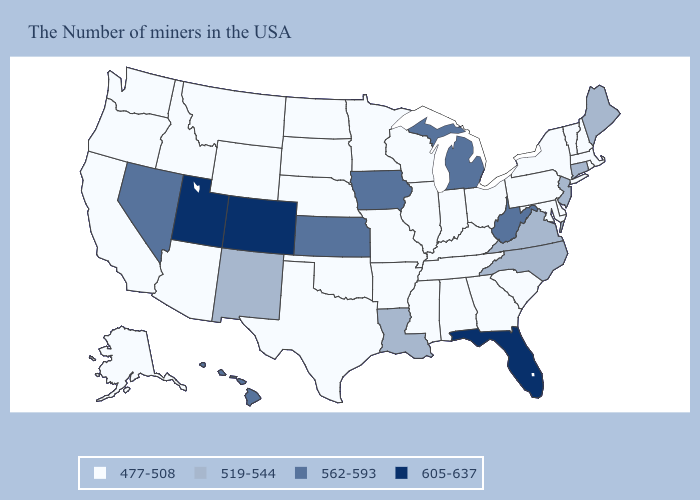Which states hav the highest value in the West?
Keep it brief. Colorado, Utah. Name the states that have a value in the range 477-508?
Write a very short answer. Massachusetts, Rhode Island, New Hampshire, Vermont, New York, Delaware, Maryland, Pennsylvania, South Carolina, Ohio, Georgia, Kentucky, Indiana, Alabama, Tennessee, Wisconsin, Illinois, Mississippi, Missouri, Arkansas, Minnesota, Nebraska, Oklahoma, Texas, South Dakota, North Dakota, Wyoming, Montana, Arizona, Idaho, California, Washington, Oregon, Alaska. Does Louisiana have a higher value than Indiana?
Write a very short answer. Yes. Which states have the lowest value in the USA?
Be succinct. Massachusetts, Rhode Island, New Hampshire, Vermont, New York, Delaware, Maryland, Pennsylvania, South Carolina, Ohio, Georgia, Kentucky, Indiana, Alabama, Tennessee, Wisconsin, Illinois, Mississippi, Missouri, Arkansas, Minnesota, Nebraska, Oklahoma, Texas, South Dakota, North Dakota, Wyoming, Montana, Arizona, Idaho, California, Washington, Oregon, Alaska. What is the value of Florida?
Write a very short answer. 605-637. What is the value of Illinois?
Short answer required. 477-508. Does Ohio have a lower value than North Carolina?
Give a very brief answer. Yes. What is the highest value in the USA?
Keep it brief. 605-637. What is the highest value in the Northeast ?
Answer briefly. 519-544. What is the value of Missouri?
Write a very short answer. 477-508. Which states have the lowest value in the USA?
Write a very short answer. Massachusetts, Rhode Island, New Hampshire, Vermont, New York, Delaware, Maryland, Pennsylvania, South Carolina, Ohio, Georgia, Kentucky, Indiana, Alabama, Tennessee, Wisconsin, Illinois, Mississippi, Missouri, Arkansas, Minnesota, Nebraska, Oklahoma, Texas, South Dakota, North Dakota, Wyoming, Montana, Arizona, Idaho, California, Washington, Oregon, Alaska. Name the states that have a value in the range 605-637?
Concise answer only. Florida, Colorado, Utah. Among the states that border Iowa , which have the highest value?
Give a very brief answer. Wisconsin, Illinois, Missouri, Minnesota, Nebraska, South Dakota. What is the highest value in the Northeast ?
Keep it brief. 519-544. 